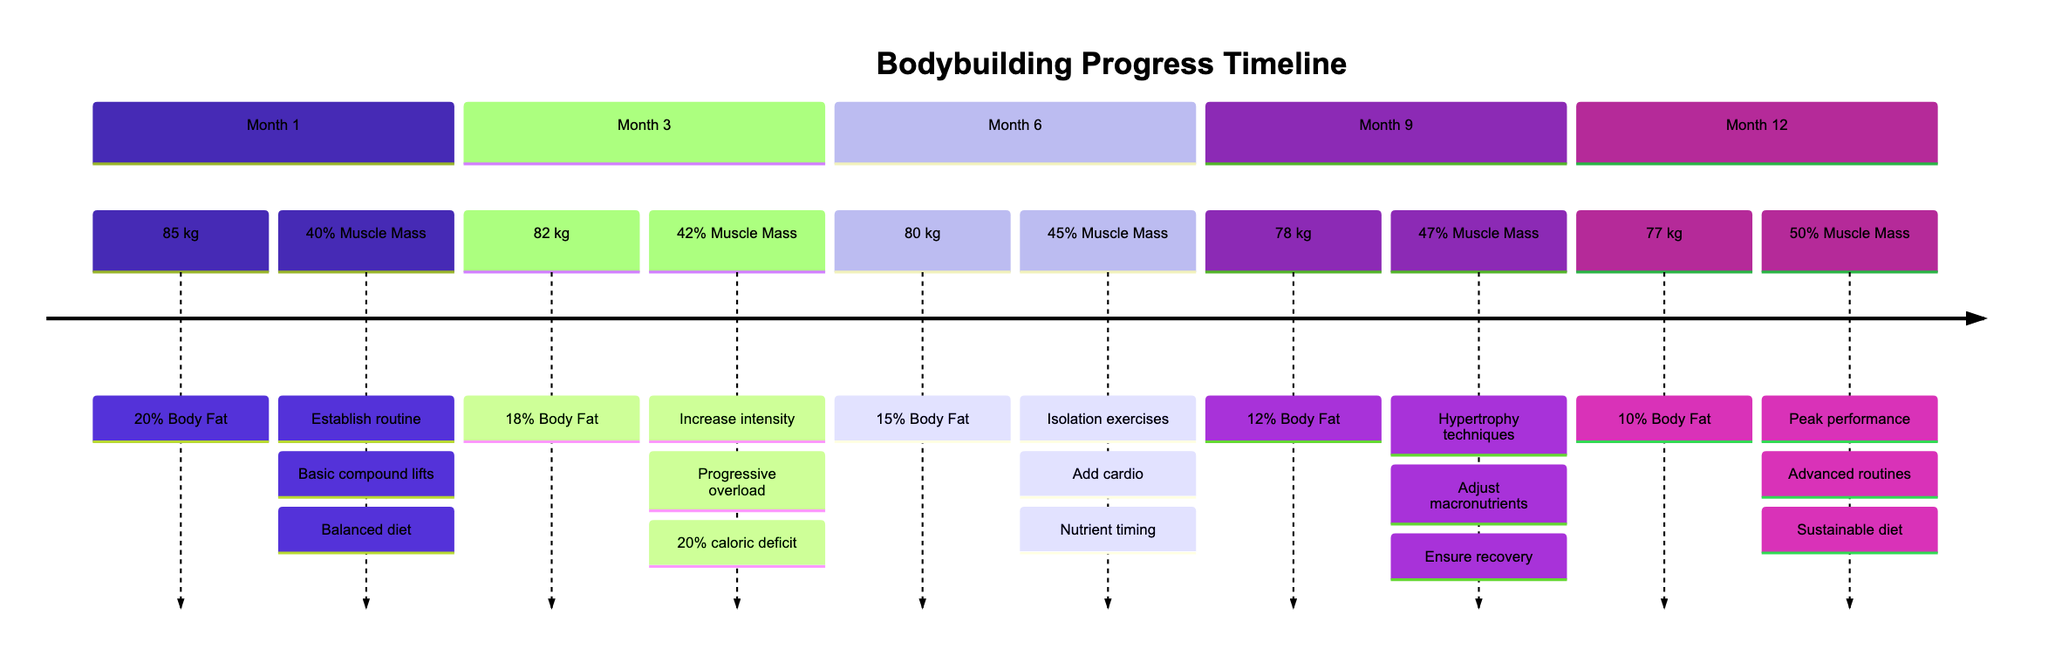What was the weight at Month 6? The diagram shows the weight listed under Month 6 as 80 kg. This information can be found directly in the corresponding section of the timeline.
Answer: 80 kg What was the body fat percentage at Month 12? At Month 12, the body fat percentage is clearly stated as 10% in that section of the diagram.
Answer: 10% In which month did the muscle mass first reach 45%? The muscle mass reached 45% in Month 6, as indicated in that section of the timeline.
Answer: Month 6 How much weight was lost from Month 1 to Month 9? The weight decreased from 85 kg in Month 1 to 78 kg in Month 9. To find the weight lost, subtract 78 kg from 85 kg, which equals 7 kg.
Answer: 7 kg What key activity was present in both Month 3 and Month 6? Both Month 3 and Month 6 include key activities that mention adjusting or optimizing training intensity, which can be seen under the respective sections where it states "Increased intensity" and "Introducing more isolation exercises."
Answer: Adjusting training intensity What is the body fat percentage decrease from Month 1 to Month 12? The body fat percentage decreased from 20% in Month 1 to 10% in Month 12. To find the decrease, subtract 10% from 20%, resulting in a 10% decrease.
Answer: 10% Which month had the highest muscle mass percentage? Month 12 had the highest muscle mass percentage listed as 50%, which can be found in the final section of the timeline.
Answer: Month 12 What was the focus of training in Month 9? In Month 9, the focus of training included hypertrophy training techniques like drop sets and supersets, as stated in the key activities section.
Answer: Hypertrophy training What was the weight at Month 1? The weight for Month 1 is specifically stated as 85 kg in that section of the timeline.
Answer: 85 kg What nutritional approach was refined in Month 6? In Month 6, the nutritional approach refined was nutrient timing, which is explicitly noted in that section under key activities.
Answer: Nutrient timing 